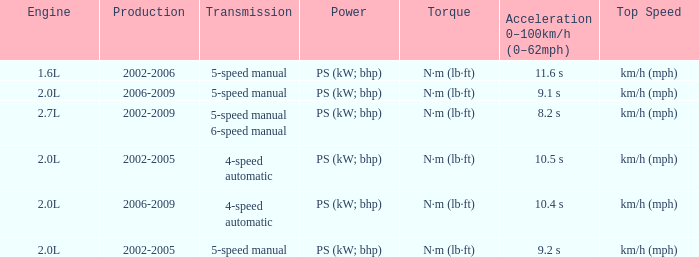What is the acceleration 0-100km/h that was produced in 2002-2006? 11.6 s. 